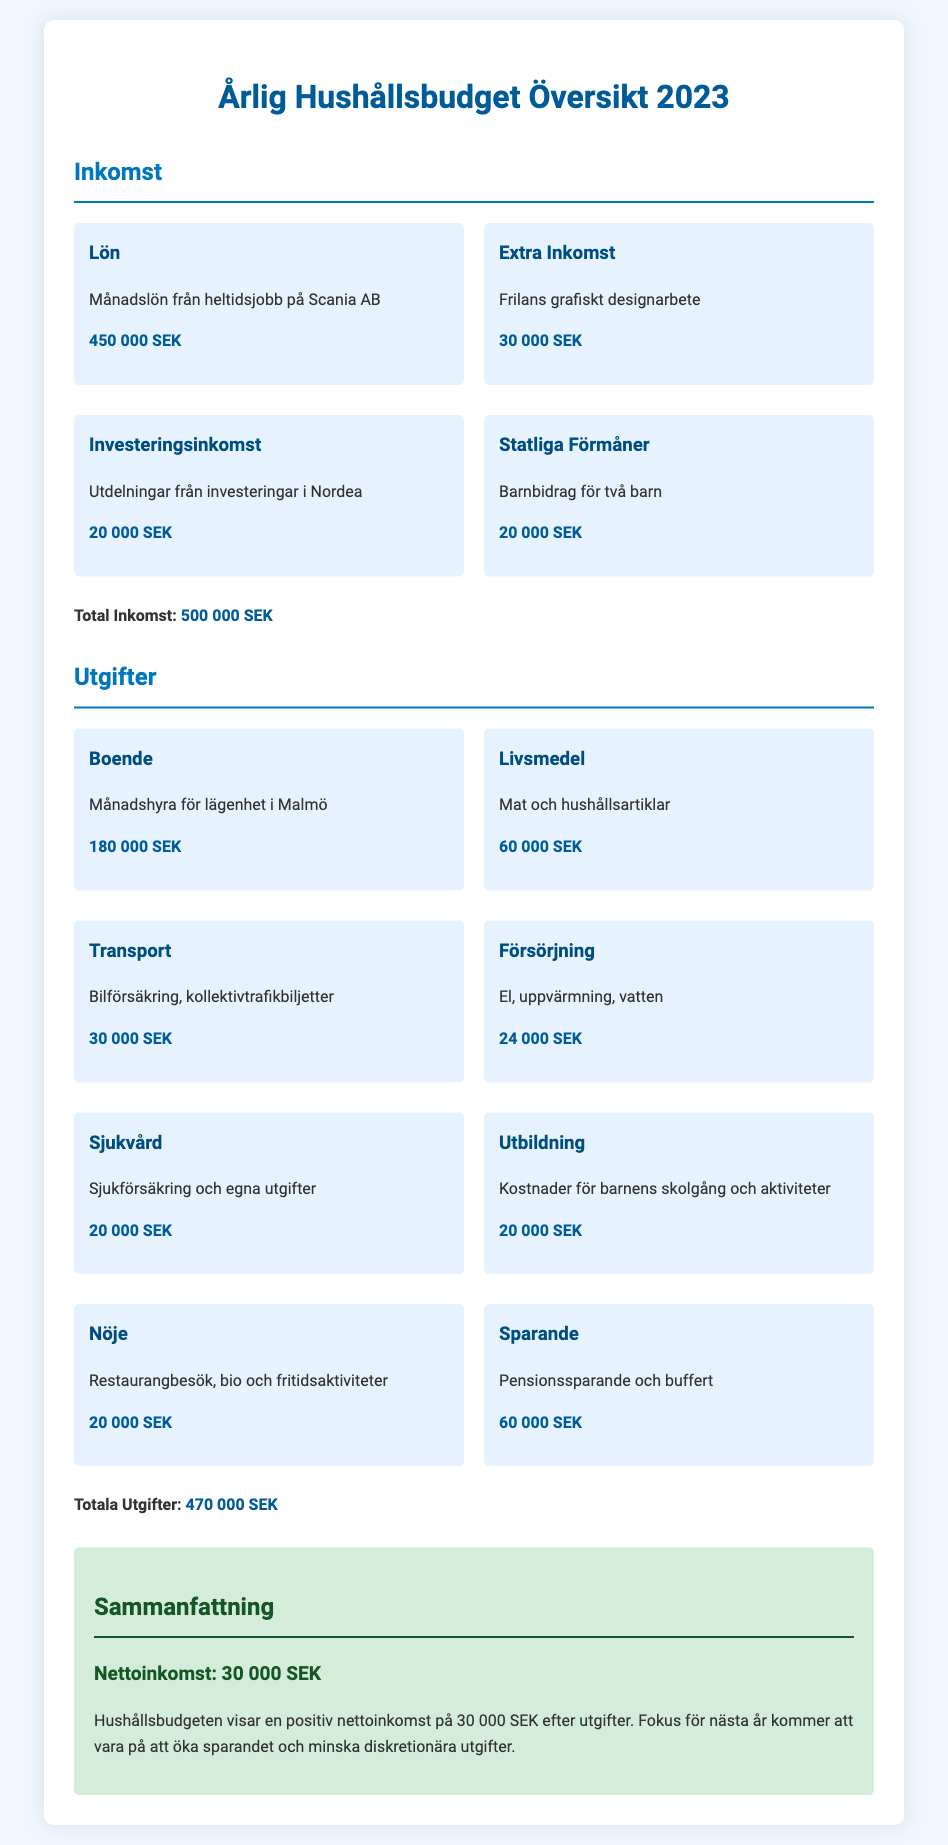What is the total income? The total income is listed at the end of the income section, which sums up all sources of income.
Answer: 500 000 SEK What is the amount spent on housing? The housing category lists the monthly rent for the apartment, indicating the total expenditure for that category.
Answer: 180 000 SEK How much is allocated for savings? The savings category outlines the amount set aside for pension savings and emergency funds.
Answer: 60 000 SEK What is the net income for the year? The net income is summarized at the end of the document as the difference between total income and total expenditures.
Answer: 30 000 SEK What category incurs the highest expense? The expenditure categories detail costs, with housing being the most significant expense listed.
Answer: Boende What is the amount received from government benefits? The income section specifies the benefits received, particularly naming the child allowance.
Answer: 20 000 SEK How much is spent on healthcare? The healthcare category details costs related to insurance and personal expenses for health.
Answer: 20 000 SEK What is the total expenditure? The total expenditure is provided at the conclusion of the expenditure section, summarizing all expenses.
Answer: 470 000 SEK What is the focus for the next year? The summary discusses future goals for the household budget, indicating priorities going forward.
Answer: Öka sparandet 